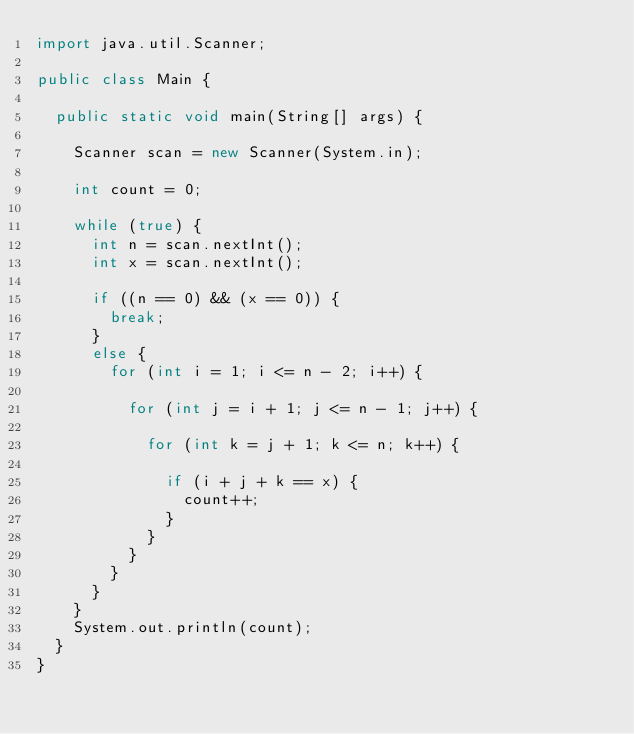Convert code to text. <code><loc_0><loc_0><loc_500><loc_500><_Java_>import java.util.Scanner;

public class Main {

	public static void main(String[] args) {

		Scanner scan = new Scanner(System.in);

		int count = 0;

		while (true) {
			int n = scan.nextInt();
			int x = scan.nextInt();

			if ((n == 0) && (x == 0)) {
				break;
			} 
			else {
				for (int i = 1; i <= n - 2; i++) {

					for (int j = i + 1; j <= n - 1; j++) {

						for (int k = j + 1; k <= n; k++) {

							if (i + j + k == x) {
								count++;
							}
						}
					}
				}
			}
		}
		System.out.println(count);
	}
}</code> 